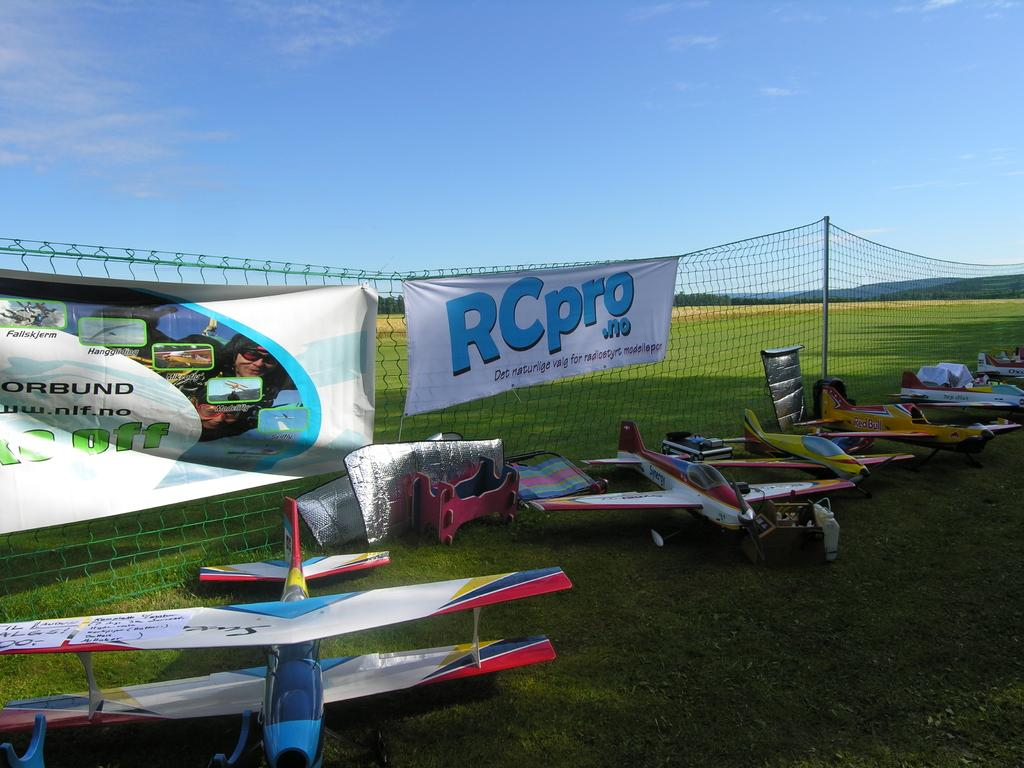<image>
Write a terse but informative summary of the picture. A white sign on a fence reads "RCpro". 